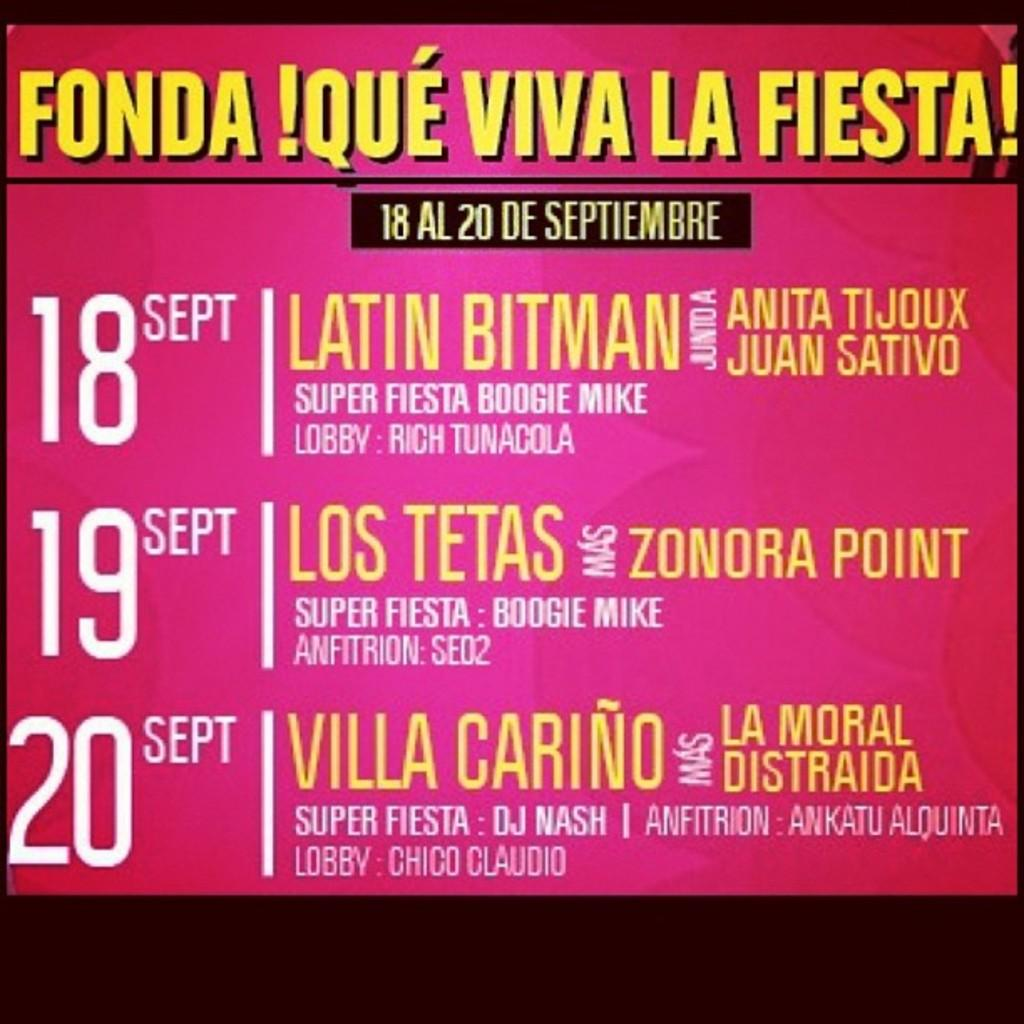Provide a one-sentence caption for the provided image. A poster advertises Fonda Que Viva La Fiesta, September 18 - 20. 